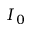<formula> <loc_0><loc_0><loc_500><loc_500>I _ { 0 }</formula> 